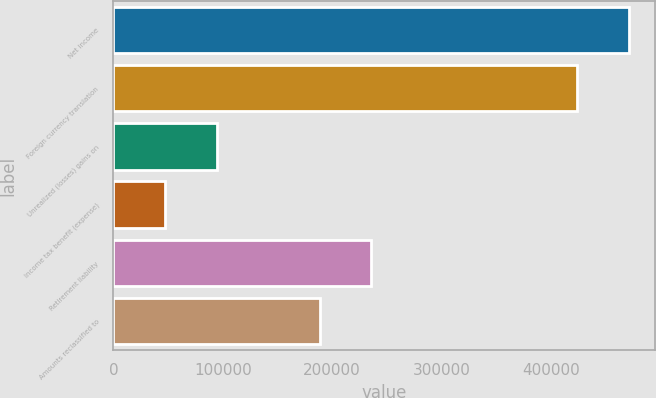Convert chart. <chart><loc_0><loc_0><loc_500><loc_500><bar_chart><fcel>Net income<fcel>Foreign currency translation<fcel>Unrealized (losses) gains on<fcel>Income tax benefit (expense)<fcel>Retirement liability<fcel>Amounts reclassified to<nl><fcel>471103<fcel>423995<fcel>94242.2<fcel>47134.6<fcel>235565<fcel>188457<nl></chart> 